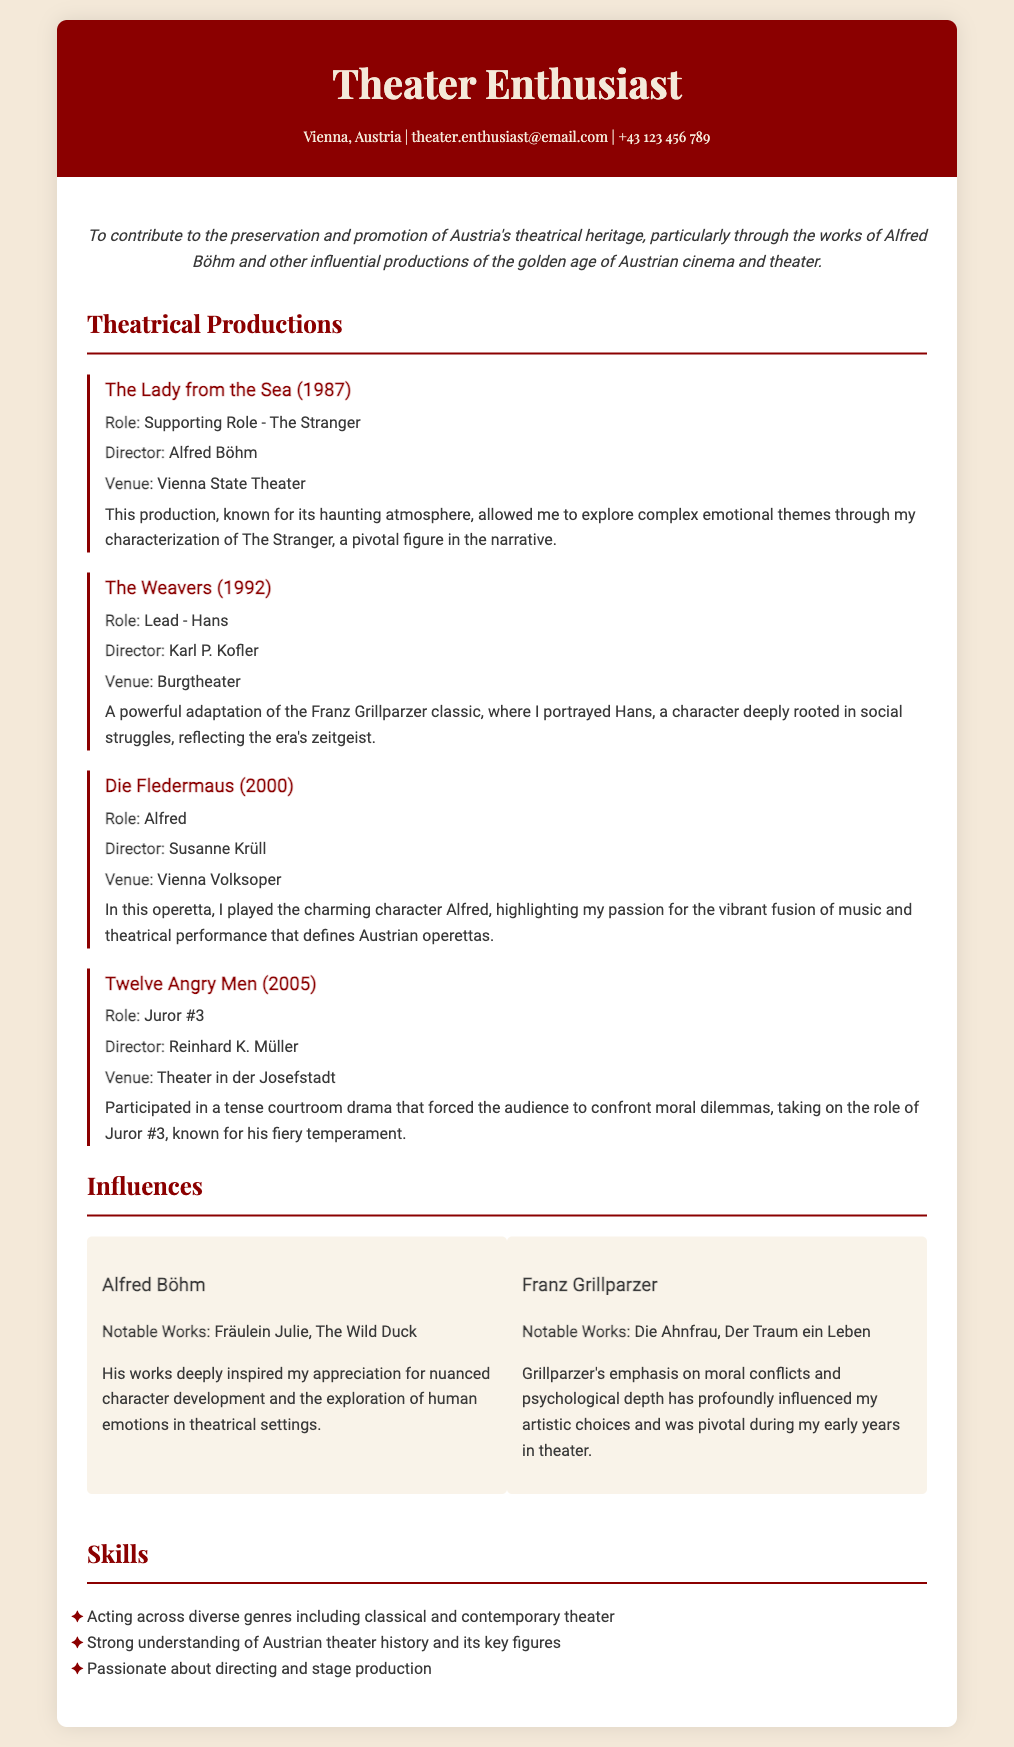What role did you play in "The Lady from the Sea"? The role played in "The Lady from the Sea" is explicitly mentioned in the document as "Supporting Role - The Stranger".
Answer: Supporting Role - The Stranger Who directed "The Weavers"? The document lists Karl P. Kofler as the director of "The Weavers".
Answer: Karl P. Kofler What venue hosted the production of "Die Fledermaus"? The venue for "Die Fledermaus" is specified in the document as Vienna Volksoper.
Answer: Vienna Volksoper Which character did you portray in "Twelve Angry Men"? The document states that the role taken was "Juror #3".
Answer: Juror #3 What year was "Die Fledermaus" performed? The document indicates that "Die Fledermaus" was performed in 2000.
Answer: 2000 Which influential figure's works inspired the author, as mentioned in the influences section? The document mentions Alfred Böhm as a significant influence on the author.
Answer: Alfred Böhm What is the objective stated in the CV? The document provides an objective focused on preserving and promoting Austria's theatrical heritage, particularly through the works of Alfred Böhm.
Answer: To contribute to the preservation and promotion of Austria's theatrical heritage How many productions are listed in the theatrical productions section? By counting the productions detailed in the document, there are four listed.
Answer: Four What is one of the notable works of Franz Grillparzer mentioned? The document lists "Die Ahnfrau" as one of the notable works of Franz Grillparzer.
Answer: Die Ahnfrau 